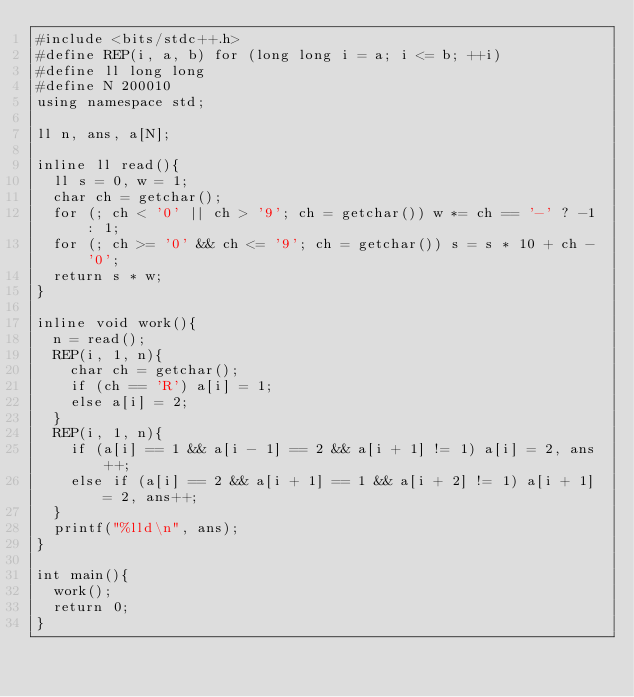Convert code to text. <code><loc_0><loc_0><loc_500><loc_500><_C++_>#include <bits/stdc++.h>
#define REP(i, a, b) for (long long i = a; i <= b; ++i)
#define ll long long
#define N 200010
using namespace std;

ll n, ans, a[N];

inline ll read(){
	ll s = 0, w = 1;
	char ch = getchar();
	for (; ch < '0' || ch > '9'; ch = getchar()) w *= ch == '-' ? -1 : 1;
	for (; ch >= '0' && ch <= '9'; ch = getchar()) s = s * 10 + ch - '0';
	return s * w;
}

inline void work(){
	n = read();
	REP(i, 1, n){
		char ch = getchar();
		if (ch == 'R') a[i] = 1;
		else a[i] = 2;
	}
	REP(i, 1, n){
		if (a[i] == 1 && a[i - 1] == 2 && a[i + 1] != 1) a[i] = 2, ans++;
		else if (a[i] == 2 && a[i + 1] == 1 && a[i + 2] != 1) a[i + 1] = 2, ans++;
	}
	printf("%lld\n", ans);
}

int main(){
	work();
	return 0;
}</code> 